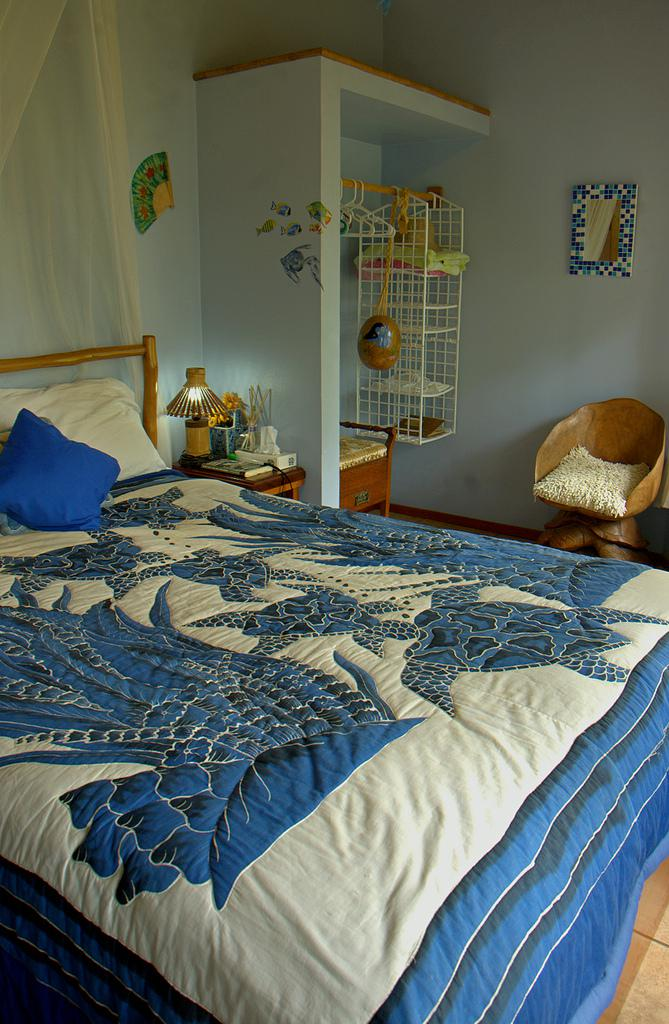Question: what type of room?
Choices:
A. Bedroom.
B. Living room.
C. Bathroom.
D. Kitchen.
Answer with the letter. Answer: A Question: how do people sleep?
Choices:
A. On the couch.
B. In the tent.
C. On the bed.
D. On the floor.
Answer with the letter. Answer: C Question: what is in the corner?
Choices:
A. An umbrella.
B. A broom.
C. Empty plastic hangers.
D. A lamp.
Answer with the letter. Answer: C Question: what is displayed on the bedspread?
Choices:
A. An underwater scene with turtles.
B. Palm trees.
C. Seashells.
D. Owls.
Answer with the letter. Answer: A Question: why is the wall in the corner designed with an angle?
Choices:
A. For aesthetic purposes.
B. It's the best design.
C. To support a rack.
D. There's not enough room for it to not be at an angle.
Answer with the letter. Answer: C Question: how many shades of tan does the floor have?
Choices:
A. One.
B. Two.
C. Three.
D. Four.
Answer with the letter. Answer: B Question: where is the small wood bench?
Choices:
A. The porch.
B. The den.
C. The bedroom.
D. Closet area.
Answer with the letter. Answer: D Question: what is giving off light?
Choices:
A. The television.
B. The table lamp.
C. The overhead lights.
D. The computer.
Answer with the letter. Answer: B Question: where does the chair sit?
Choices:
A. On the floor.
B. Atop a carved turtle.
C. On the porch.
D. By the table.
Answer with the letter. Answer: B Question: what is applique embroidered?
Choices:
A. The shirt.
B. The pants.
C. The quilt.
D. The jacket.
Answer with the letter. Answer: C Question: what color mirror is on the wall?
Choices:
A. Black.
B. Red.
C. Blue.
D. Blue and white.
Answer with the letter. Answer: D 